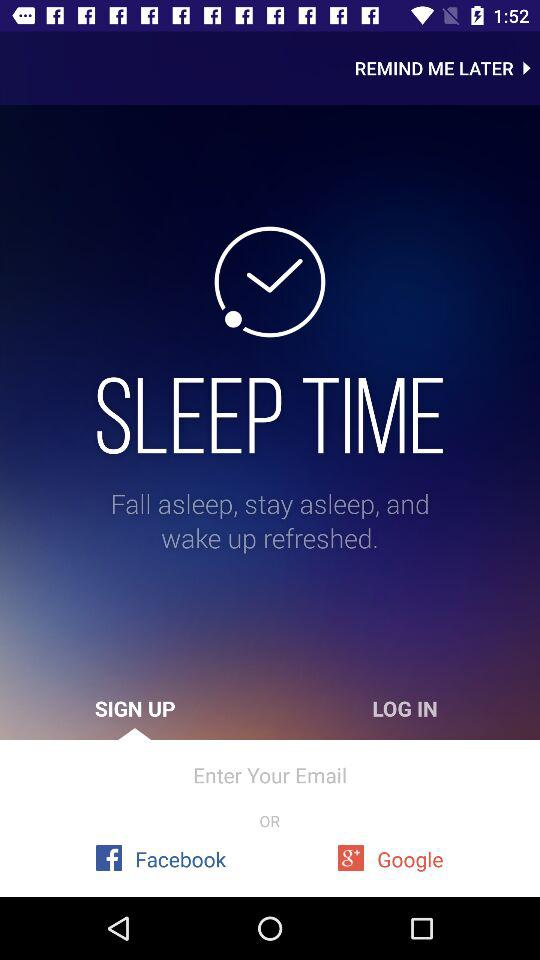What accounts can be used to sign up? The accounts are "Email", "Facebook" and "Google". 